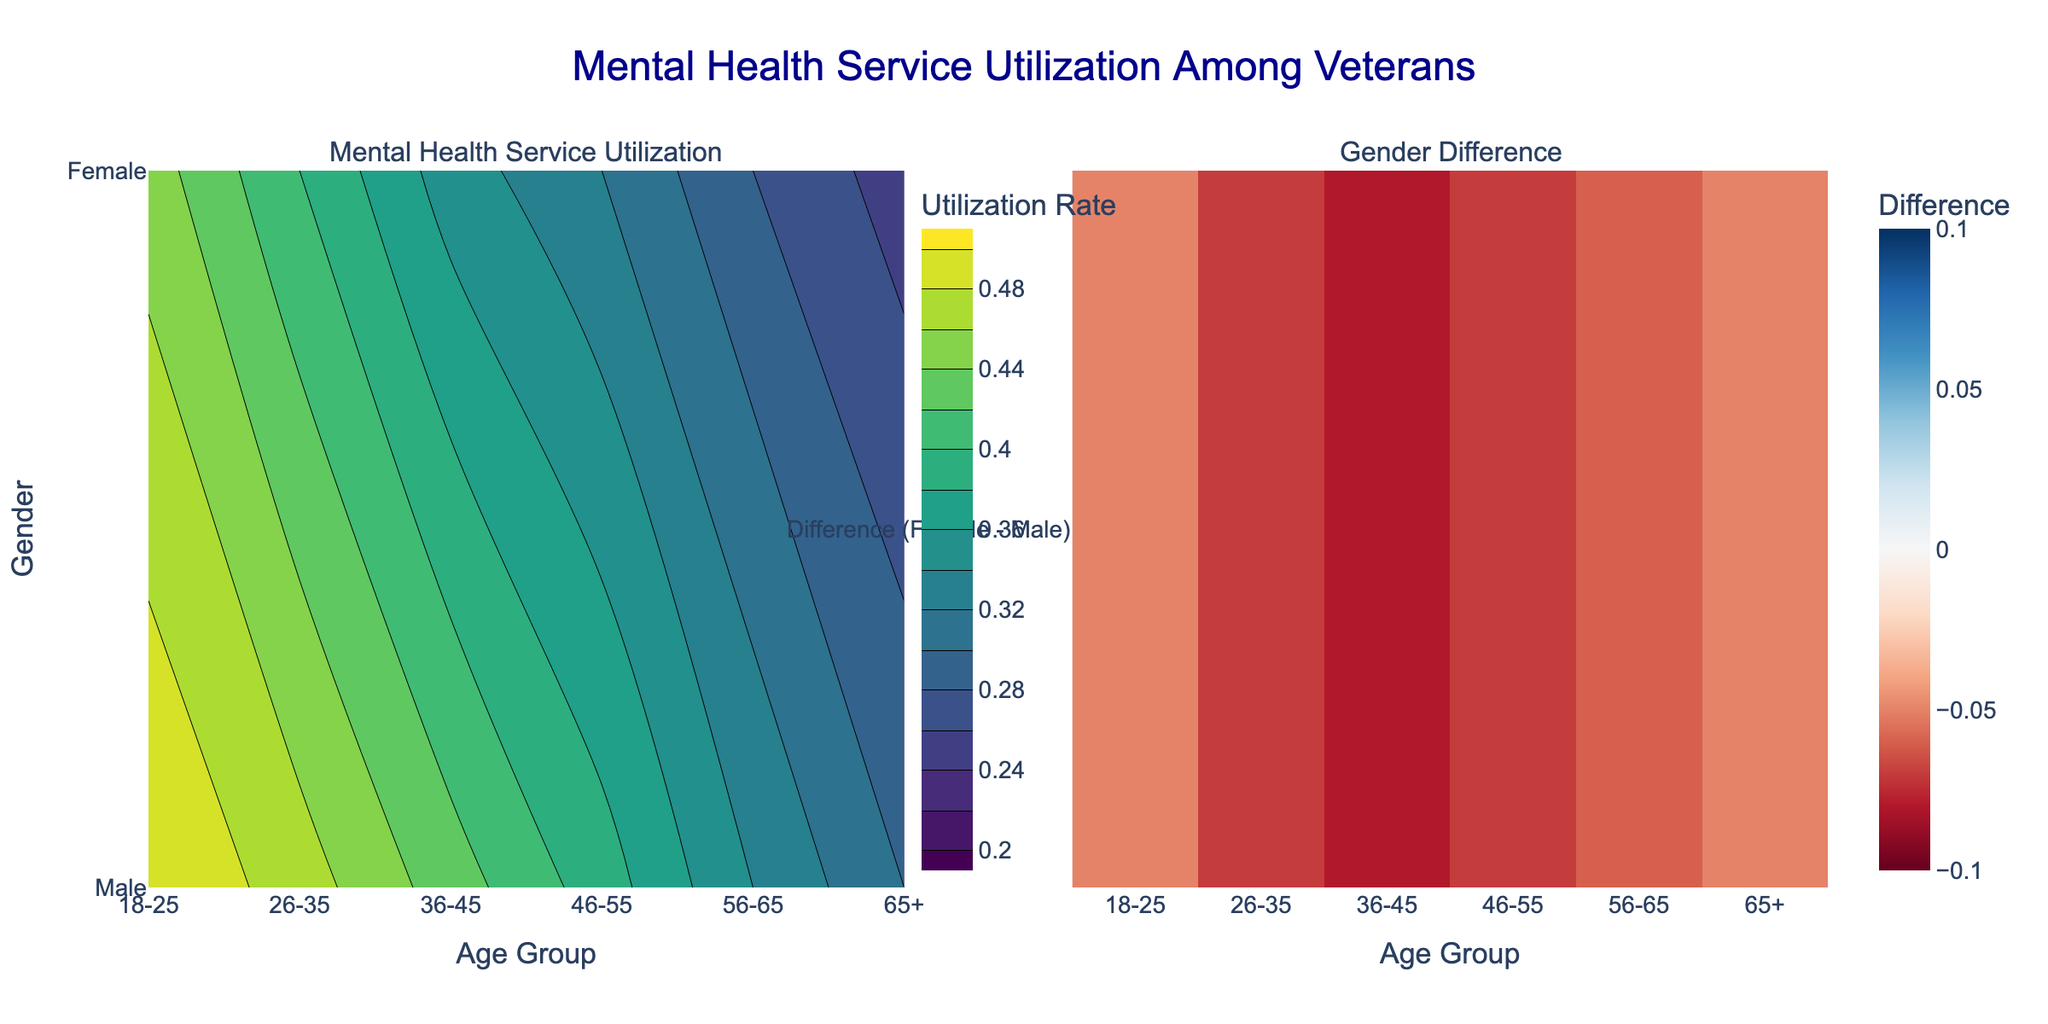What is the title of the figure? The title of the figure is displayed at the top center in a large font. It reads "Mental Health Service Utilization Among Veterans".
Answer: Mental Health Service Utilization Among Veterans What are the labels for the x-axis and y-axis of the first subplot? The labels are located next to the axes. The x-axis is labeled "Age Group" and the y-axis is labeled "Gender".
Answer: Age Group and Gender What is the color indicating the highest utilization rate in the contour plot? The color scale next to the first subplot shows the range of colors. The highest utilization rate corresponds to the darkest green color in the 'Viridis' scale.
Answer: Dark green What is the utilization rate for females aged 26-35? Hovering over the corresponding cell in the contour plot or checking the specific color on the color scale shows the utilization rate for this group. It is around 0.47.
Answer: 0.47 Which gender shows a higher utilization rate for the age group 46-55? By comparing the colors in the contour plot for the age group 46-55, females have a lighter color indicating a higher utilization rate. The heatmap also shows a positive difference for this group.
Answer: Female What is the difference in utilization rates between females and males aged 36-45? The heatmap in the second subplot shows this difference directly. It indicates that the difference for this age group is around 0.08 in favor of females.
Answer: 0.08 In which age group is the utilization rate for males the lowest? By looking at the colors of the contour plot for males across different age groups, the age group '65+' has the darkest color indicating the lowest utilization rate.
Answer: 65+ How does the utilization rate for females aged 56-65 compare to females aged 36-45? By comparing the colors in the contour plot for these age groups, females aged 36-45 have a slightly lighter color than those aged 56-65, indicating a higher utilization rate.
Answer: 36-45 Which contour plot value indicates the age group with the largest gender difference in utilization rates? The second subplot (Heatmap) indicates the gender difference directly. The brightest red color, indicating the largest positive difference, is seen for the age group 36-45.
Answer: 36-45 What is the range of utilization rates shown in the contour plot? The color bar for the contour plot shows the range of utilization rates, which start at 0.2 and end at 0.5.
Answer: 0.2 to 0.5 